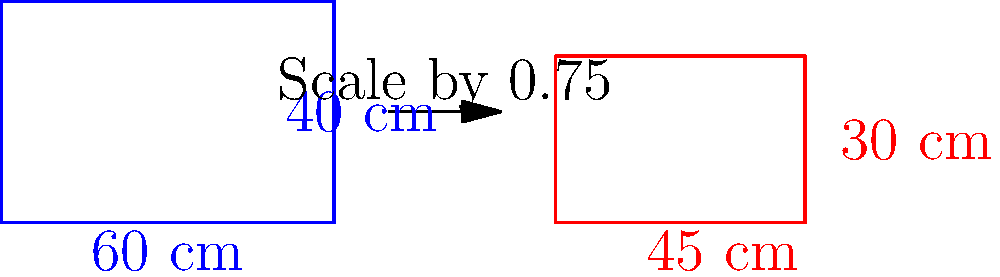As a security officer at Incheon International Airport, you're tasked with enforcing carry-on luggage regulations. A passenger's suitcase measures 60 cm x 40 cm, exceeding the airline's 55 cm x 35 cm limit. If the luggage is uniformly scaled down to meet the maximum allowed width of 55 cm, what will be the new height of the luggage to the nearest centimeter? Let's approach this step-by-step:

1) First, we need to find the scale factor. We know the original width is 60 cm and it needs to be reduced to 55 cm.

   Scale factor = New width / Original width
                = 55 cm / 60 cm
                = 0.9166...

2) This scale factor will be applied uniformly to both dimensions of the luggage.

3) To find the new height, we multiply the original height by the scale factor:

   New height = Original height × Scale factor
              = 40 cm × 0.9166...
              = 36.66... cm

4) Rounding to the nearest centimeter:

   36.66... cm ≈ 37 cm

Therefore, when scaled down to fit the width requirement, the new height of the luggage will be approximately 37 cm.
Answer: 37 cm 